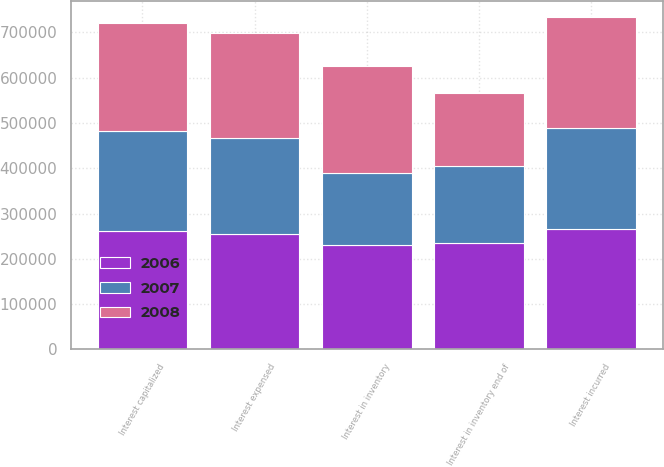<chart> <loc_0><loc_0><loc_500><loc_500><stacked_bar_chart><ecel><fcel>Interest in inventory<fcel>Interest capitalized<fcel>Interest expensed<fcel>Interest in inventory end of<fcel>Interest incurred<nl><fcel>2007<fcel>160598<fcel>220131<fcel>210709<fcel>170020<fcel>223039<nl><fcel>2008<fcel>235596<fcel>240000<fcel>232697<fcel>160598<fcel>243864<nl><fcel>2006<fcel>229798<fcel>261486<fcel>255688<fcel>235596<fcel>266561<nl></chart> 